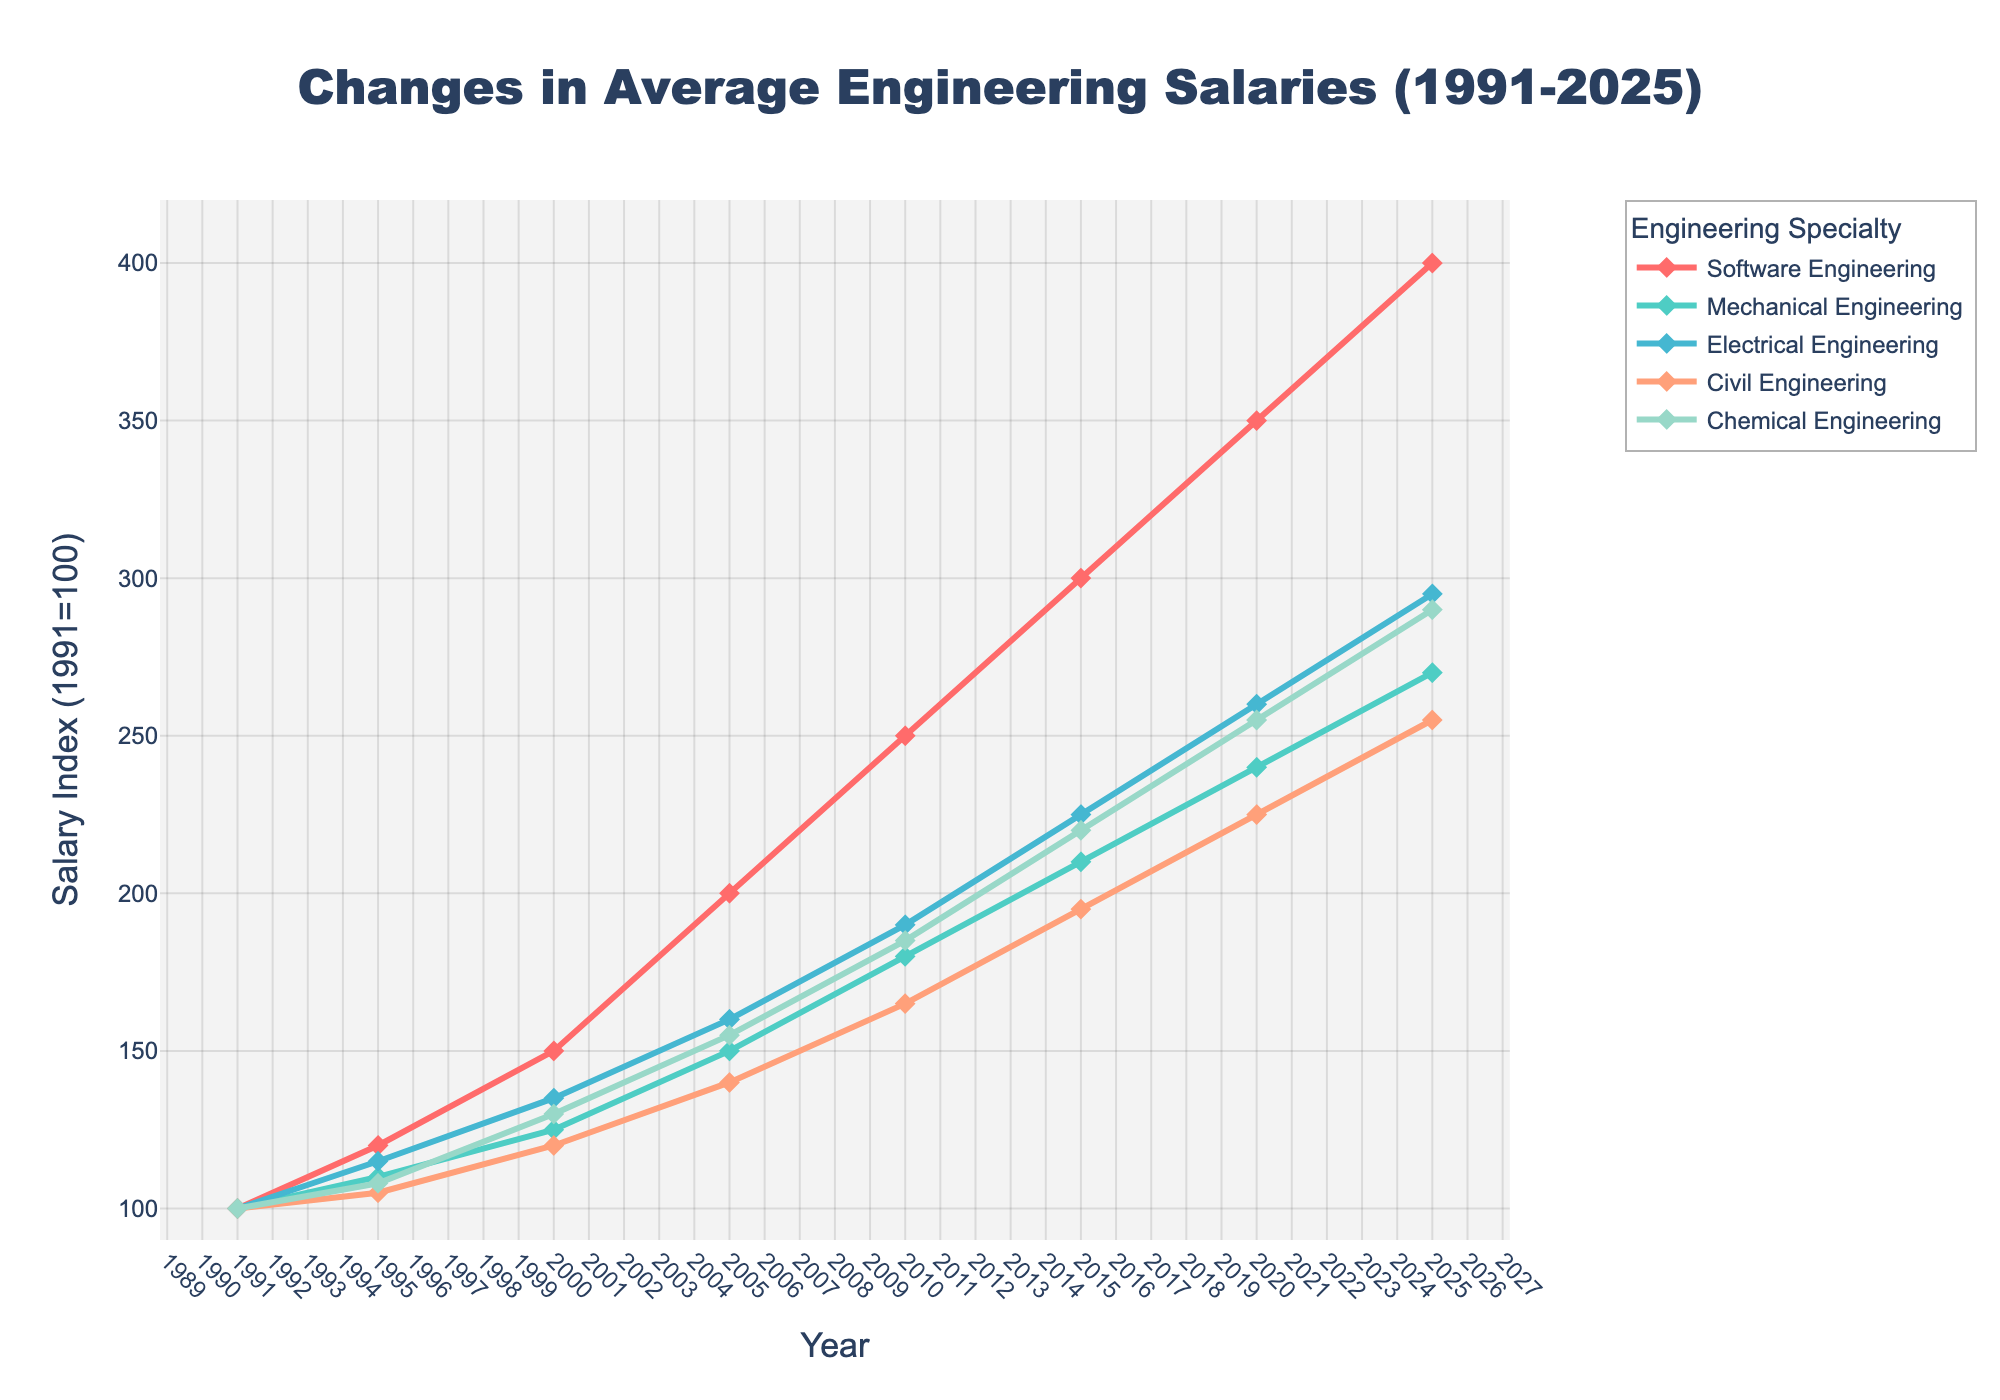What's the difference in salary index increase for Software Engineering and Civil Engineering from 1991 to 2025? Look at the values for Software Engineering and Civil Engineering in 1991 and 2025. For Software Engineering: 400 - 100 = 300. For Civil Engineering: 255 - 100 = 155. The difference is 300 - 155 = 145.
Answer: 145 Which engineering specialty had the highest salary index in 2025? Refer to the 2025 values for all specialties. Software Engineering has the highest value at 400.
Answer: Software Engineering By how much did the salary index for Chemical Engineering increase between 2000 and 2010? Check the values for Chemical Engineering in 2000 and 2010. The increase is 185 - 130 = 55.
Answer: 55 Which year shows the closest salary indices between Electrical Engineering and Mechanical Engineering? Compare the indices for Electrical and Mechanical Engineering across all years. In 1995, the indices are 115 (Electrical) and 110 (Mechanical), which is the smallest difference of 5.
Answer: 1995 What is the average salary index for Software Engineering over the years provided? Add the Software Engineering indices and divide by the number of years. (100 + 120 + 150 + 200 + 250 + 300 + 350 + 400) / 8 = 1870 / 8 = 233.75
Answer: 233.75 